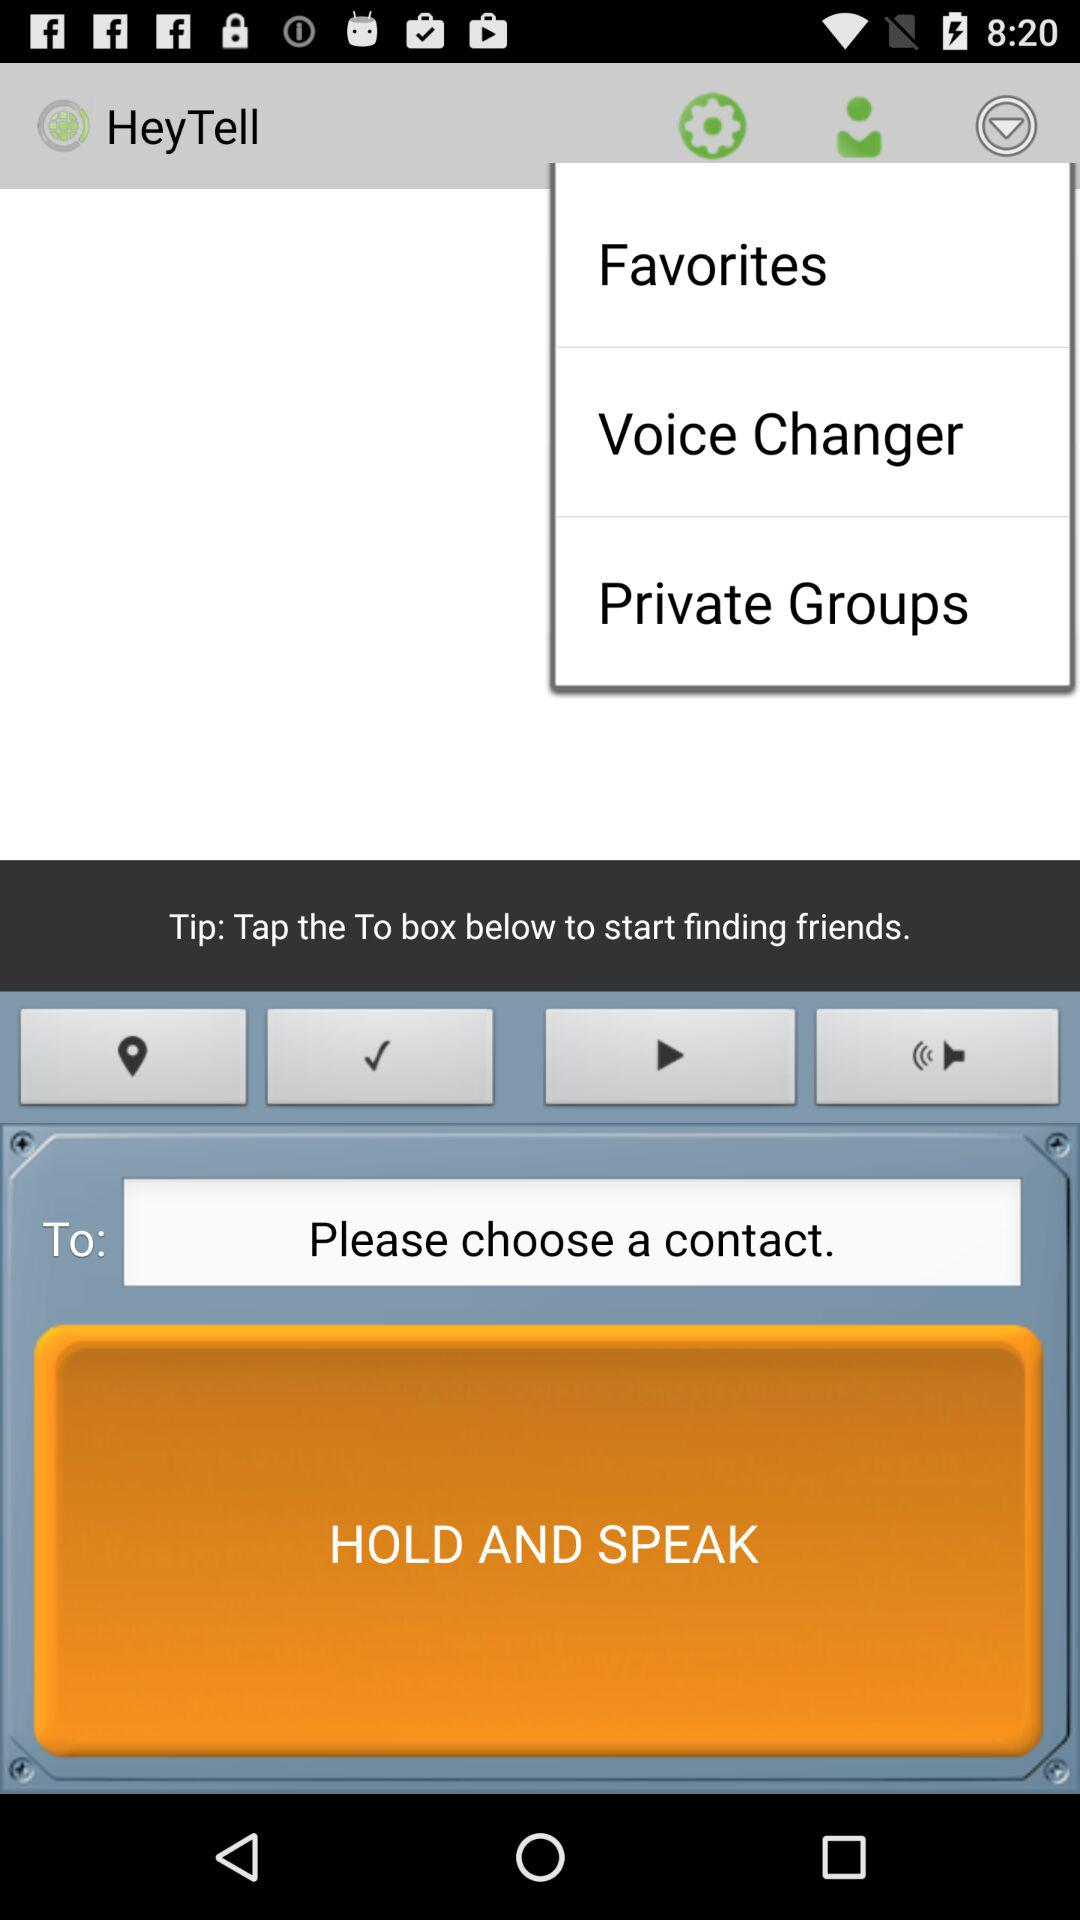What is the name of the application? The name of the application is "HeyTell". 